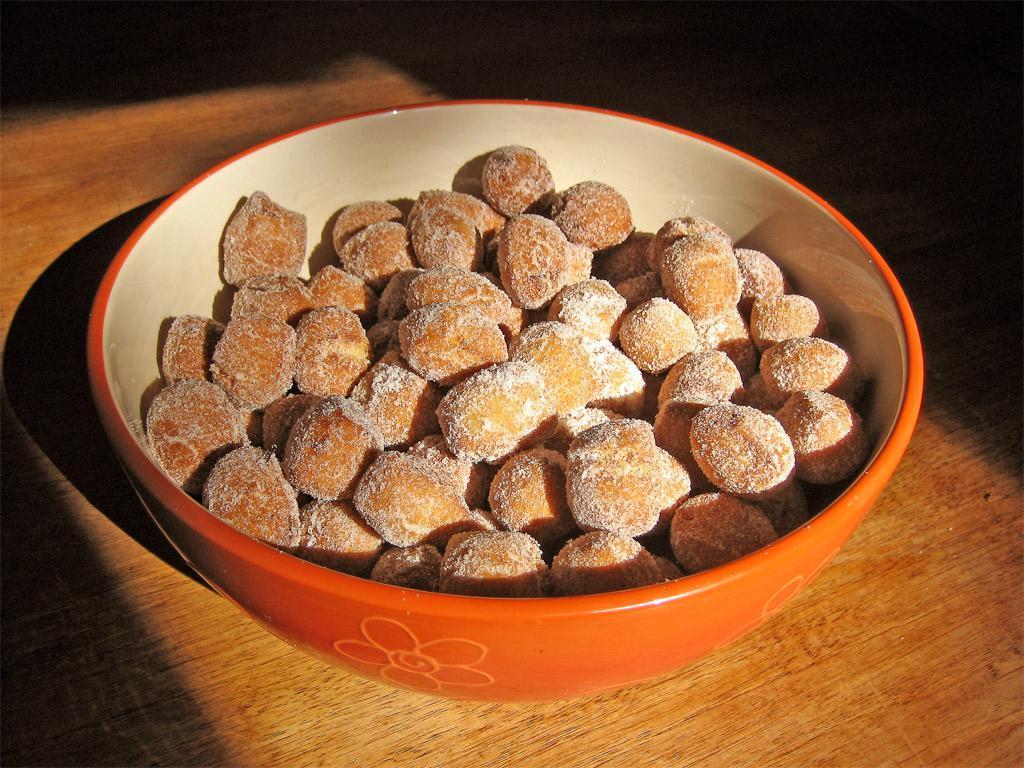Describe this image in one or two sentences. In this picture I can see a food item in a bowl, on the table. 